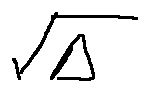Convert formula to latex. <formula><loc_0><loc_0><loc_500><loc_500>\sqrt { \Delta }</formula> 